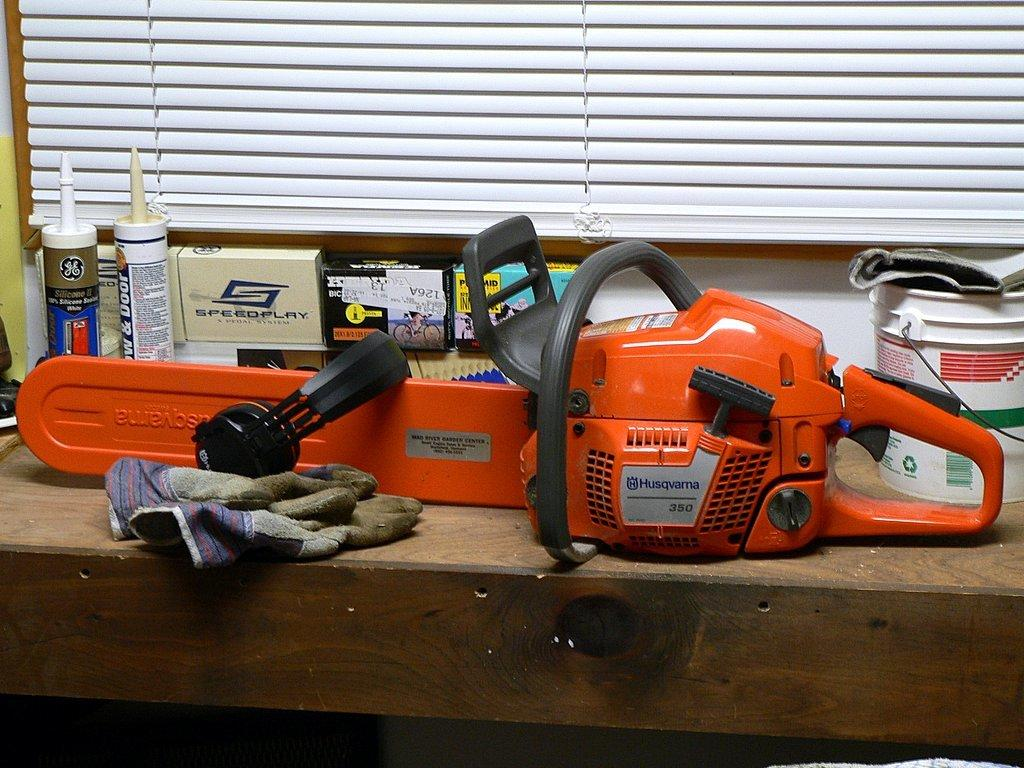What is the main object in the image? There is a machine in the image. What else can be seen on the table in the image? There is a bucket, bottles, boxes, and a cloth on the table in the image. How many types of containers are present in the image? There are three types of containers: a bucket, bottles, and boxes. Who is the friend of the machine in the image? There is no friend of the machine present in the image, as the machine is an inanimate object. Is the brother of the cloth visible in the image? There is no brother of the cloth present in the image, as the cloth is an inanimate object. 